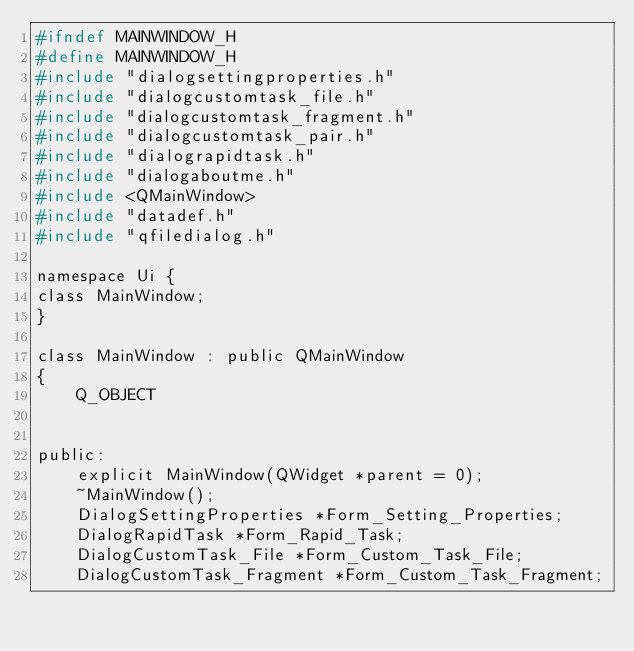Convert code to text. <code><loc_0><loc_0><loc_500><loc_500><_C_>#ifndef MAINWINDOW_H
#define MAINWINDOW_H
#include "dialogsettingproperties.h"
#include "dialogcustomtask_file.h"
#include "dialogcustomtask_fragment.h"
#include "dialogcustomtask_pair.h"
#include "dialograpidtask.h"
#include "dialogaboutme.h"
#include <QMainWindow>
#include "datadef.h"
#include "qfiledialog.h"

namespace Ui {
class MainWindow;
}

class MainWindow : public QMainWindow
{
    Q_OBJECT


public:
    explicit MainWindow(QWidget *parent = 0);
    ~MainWindow();
    DialogSettingProperties *Form_Setting_Properties;
    DialogRapidTask *Form_Rapid_Task;
    DialogCustomTask_File *Form_Custom_Task_File;
    DialogCustomTask_Fragment *Form_Custom_Task_Fragment;</code> 